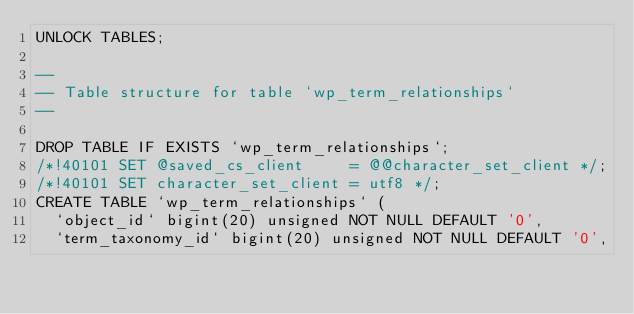Convert code to text. <code><loc_0><loc_0><loc_500><loc_500><_SQL_>UNLOCK TABLES;

--
-- Table structure for table `wp_term_relationships`
--

DROP TABLE IF EXISTS `wp_term_relationships`;
/*!40101 SET @saved_cs_client     = @@character_set_client */;
/*!40101 SET character_set_client = utf8 */;
CREATE TABLE `wp_term_relationships` (
  `object_id` bigint(20) unsigned NOT NULL DEFAULT '0',
  `term_taxonomy_id` bigint(20) unsigned NOT NULL DEFAULT '0',</code> 